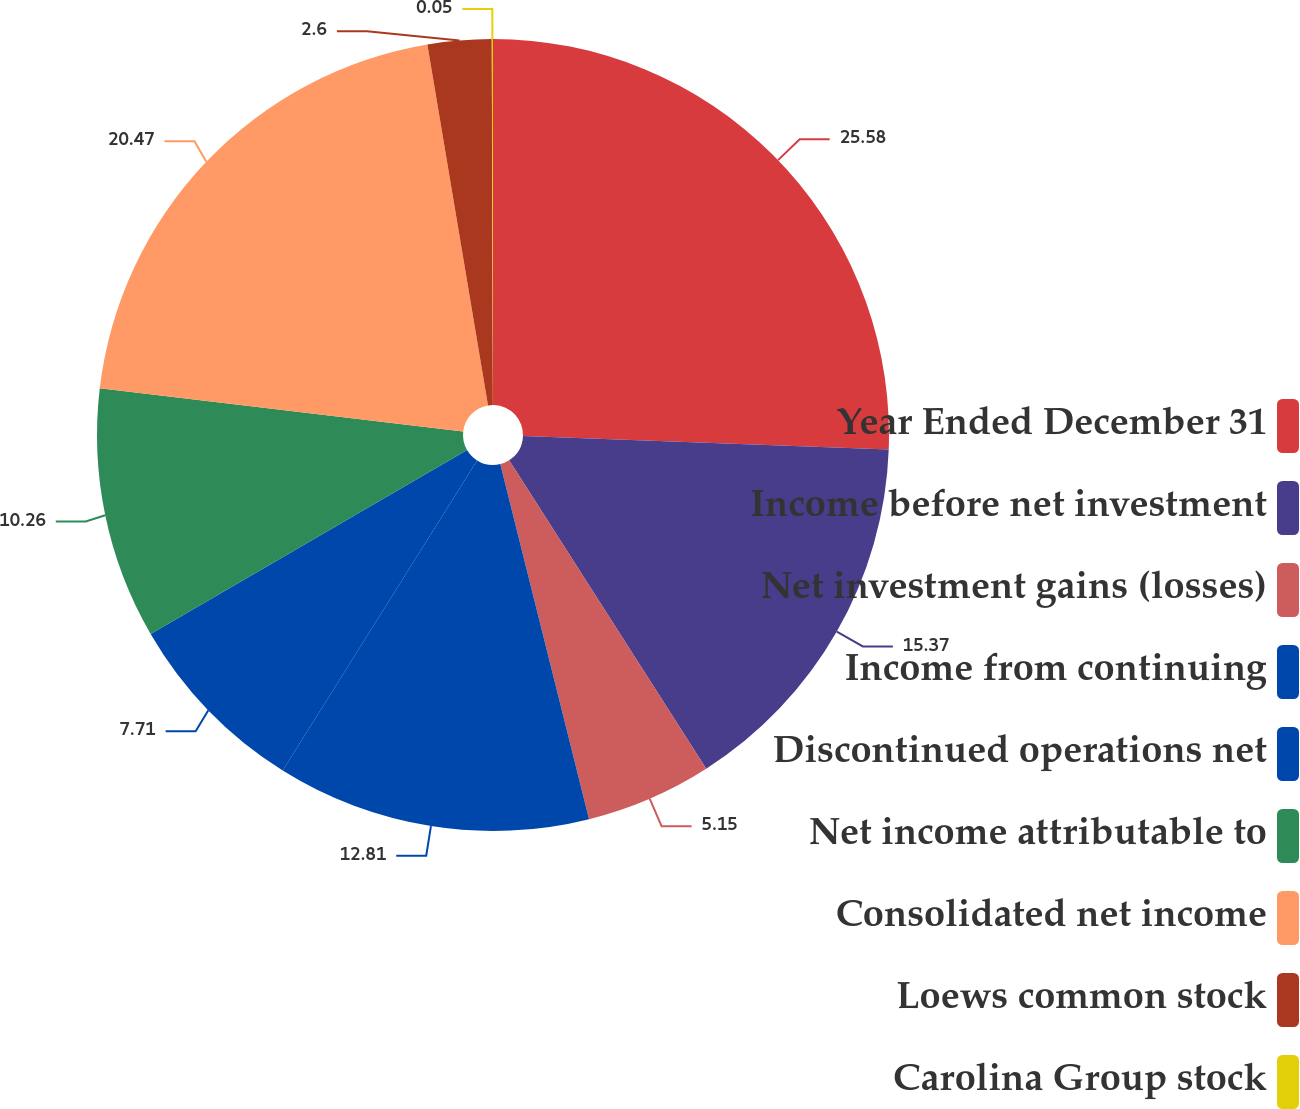Convert chart. <chart><loc_0><loc_0><loc_500><loc_500><pie_chart><fcel>Year Ended December 31<fcel>Income before net investment<fcel>Net investment gains (losses)<fcel>Income from continuing<fcel>Discontinued operations net<fcel>Net income attributable to<fcel>Consolidated net income<fcel>Loews common stock<fcel>Carolina Group stock<nl><fcel>25.58%<fcel>15.37%<fcel>5.15%<fcel>12.81%<fcel>7.71%<fcel>10.26%<fcel>20.47%<fcel>2.6%<fcel>0.05%<nl></chart> 